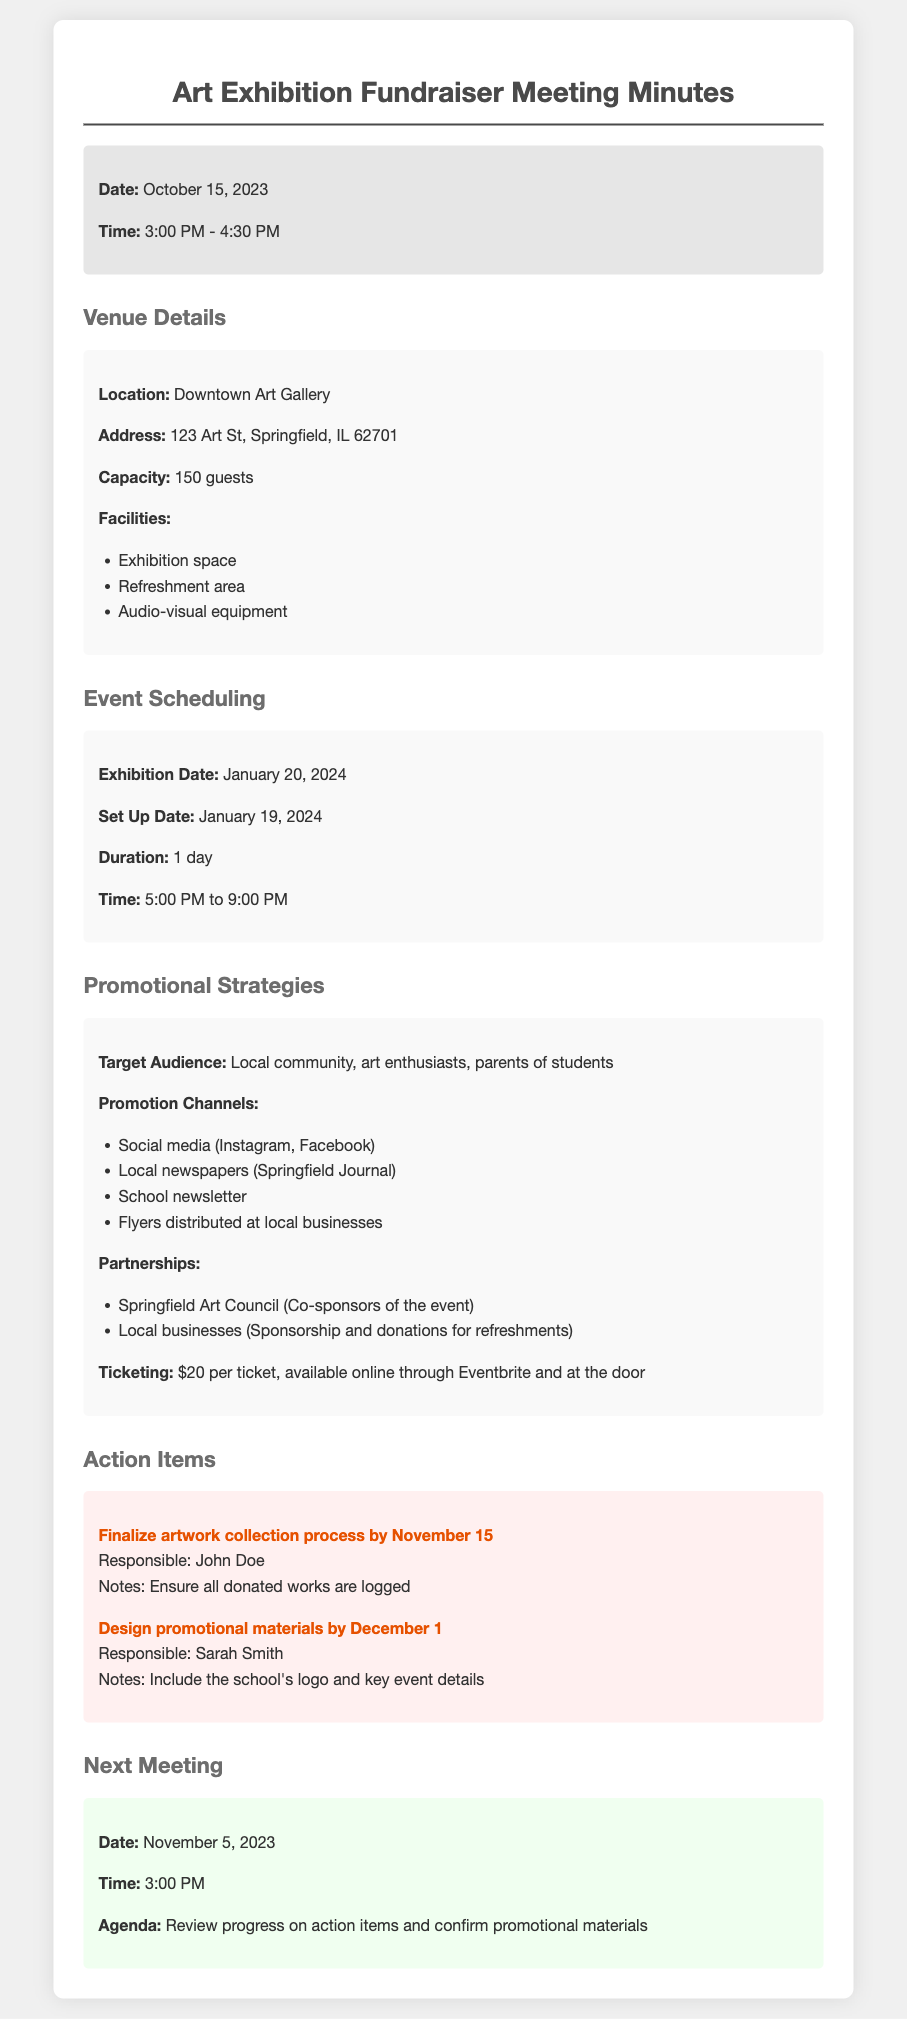What is the date of the exhibition? The date of the exhibition is mentioned in the scheduling section of the document.
Answer: January 20, 2024 What is the capacity of the venue? The capacity of the Downtown Art Gallery is specified in the venue details section.
Answer: 150 guests Who is responsible for finalizing the artwork collection process? The document lists the responsible person for this action item.
Answer: John Doe What are the promotion channels mentioned? The document lists specific channels in the promotional strategies section.
Answer: Social media, local newspapers, school newsletter, flyers What time is the next meeting scheduled for? The time for the next meeting is specified in the next meeting section.
Answer: 3:00 PM How many action items are listed? The number of action items can be counted in the action items section.
Answer: 2 What is the ticket price? The ticket price is indicated in the promotional strategies section.
Answer: $20 per ticket What is the duration of the exhibition? The duration is noted in the scheduling section of the document.
Answer: 1 day What is the address of the venue? The address of the Downtown Art Gallery is provided in the venue details section.
Answer: 123 Art St, Springfield, IL 62701 